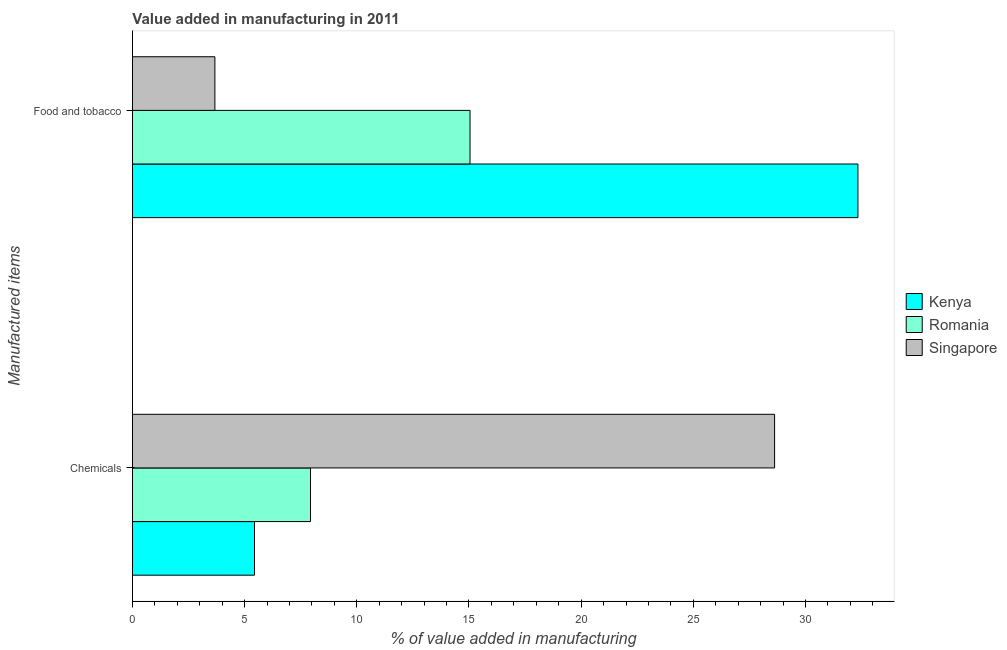Are the number of bars per tick equal to the number of legend labels?
Make the answer very short. Yes. Are the number of bars on each tick of the Y-axis equal?
Your answer should be very brief. Yes. What is the label of the 2nd group of bars from the top?
Give a very brief answer. Chemicals. What is the value added by manufacturing food and tobacco in Singapore?
Your response must be concise. 3.68. Across all countries, what is the maximum value added by  manufacturing chemicals?
Make the answer very short. 28.62. Across all countries, what is the minimum value added by  manufacturing chemicals?
Keep it short and to the point. 5.44. In which country was the value added by  manufacturing chemicals maximum?
Offer a very short reply. Singapore. In which country was the value added by manufacturing food and tobacco minimum?
Offer a terse response. Singapore. What is the total value added by manufacturing food and tobacco in the graph?
Offer a very short reply. 51.06. What is the difference between the value added by  manufacturing chemicals in Singapore and that in Kenya?
Your answer should be very brief. 23.18. What is the difference between the value added by  manufacturing chemicals in Kenya and the value added by manufacturing food and tobacco in Singapore?
Offer a very short reply. 1.76. What is the average value added by manufacturing food and tobacco per country?
Your response must be concise. 17.02. What is the difference between the value added by  manufacturing chemicals and value added by manufacturing food and tobacco in Romania?
Make the answer very short. -7.11. What is the ratio of the value added by manufacturing food and tobacco in Romania to that in Kenya?
Give a very brief answer. 0.47. In how many countries, is the value added by  manufacturing chemicals greater than the average value added by  manufacturing chemicals taken over all countries?
Offer a terse response. 1. What does the 3rd bar from the top in Food and tobacco represents?
Ensure brevity in your answer.  Kenya. What does the 1st bar from the bottom in Chemicals represents?
Ensure brevity in your answer.  Kenya. How many bars are there?
Give a very brief answer. 6. Are the values on the major ticks of X-axis written in scientific E-notation?
Ensure brevity in your answer.  No. Does the graph contain any zero values?
Offer a terse response. No. Where does the legend appear in the graph?
Offer a very short reply. Center right. How are the legend labels stacked?
Keep it short and to the point. Vertical. What is the title of the graph?
Keep it short and to the point. Value added in manufacturing in 2011. Does "Iceland" appear as one of the legend labels in the graph?
Ensure brevity in your answer.  No. What is the label or title of the X-axis?
Ensure brevity in your answer.  % of value added in manufacturing. What is the label or title of the Y-axis?
Your answer should be compact. Manufactured items. What is the % of value added in manufacturing in Kenya in Chemicals?
Ensure brevity in your answer.  5.44. What is the % of value added in manufacturing of Romania in Chemicals?
Make the answer very short. 7.94. What is the % of value added in manufacturing in Singapore in Chemicals?
Your answer should be very brief. 28.62. What is the % of value added in manufacturing of Kenya in Food and tobacco?
Give a very brief answer. 32.34. What is the % of value added in manufacturing of Romania in Food and tobacco?
Offer a terse response. 15.05. What is the % of value added in manufacturing in Singapore in Food and tobacco?
Offer a very short reply. 3.68. Across all Manufactured items, what is the maximum % of value added in manufacturing in Kenya?
Your response must be concise. 32.34. Across all Manufactured items, what is the maximum % of value added in manufacturing in Romania?
Provide a short and direct response. 15.05. Across all Manufactured items, what is the maximum % of value added in manufacturing of Singapore?
Keep it short and to the point. 28.62. Across all Manufactured items, what is the minimum % of value added in manufacturing of Kenya?
Offer a terse response. 5.44. Across all Manufactured items, what is the minimum % of value added in manufacturing of Romania?
Your response must be concise. 7.94. Across all Manufactured items, what is the minimum % of value added in manufacturing of Singapore?
Your answer should be very brief. 3.68. What is the total % of value added in manufacturing of Kenya in the graph?
Give a very brief answer. 37.78. What is the total % of value added in manufacturing of Romania in the graph?
Give a very brief answer. 22.99. What is the total % of value added in manufacturing in Singapore in the graph?
Keep it short and to the point. 32.3. What is the difference between the % of value added in manufacturing in Kenya in Chemicals and that in Food and tobacco?
Your answer should be very brief. -26.9. What is the difference between the % of value added in manufacturing in Romania in Chemicals and that in Food and tobacco?
Make the answer very short. -7.11. What is the difference between the % of value added in manufacturing in Singapore in Chemicals and that in Food and tobacco?
Give a very brief answer. 24.95. What is the difference between the % of value added in manufacturing of Kenya in Chemicals and the % of value added in manufacturing of Romania in Food and tobacco?
Your answer should be very brief. -9.61. What is the difference between the % of value added in manufacturing in Kenya in Chemicals and the % of value added in manufacturing in Singapore in Food and tobacco?
Offer a very short reply. 1.76. What is the difference between the % of value added in manufacturing in Romania in Chemicals and the % of value added in manufacturing in Singapore in Food and tobacco?
Provide a succinct answer. 4.26. What is the average % of value added in manufacturing of Kenya per Manufactured items?
Make the answer very short. 18.89. What is the average % of value added in manufacturing in Romania per Manufactured items?
Offer a terse response. 11.49. What is the average % of value added in manufacturing of Singapore per Manufactured items?
Offer a terse response. 16.15. What is the difference between the % of value added in manufacturing in Kenya and % of value added in manufacturing in Romania in Chemicals?
Your response must be concise. -2.5. What is the difference between the % of value added in manufacturing in Kenya and % of value added in manufacturing in Singapore in Chemicals?
Ensure brevity in your answer.  -23.18. What is the difference between the % of value added in manufacturing of Romania and % of value added in manufacturing of Singapore in Chemicals?
Ensure brevity in your answer.  -20.69. What is the difference between the % of value added in manufacturing of Kenya and % of value added in manufacturing of Romania in Food and tobacco?
Provide a succinct answer. 17.29. What is the difference between the % of value added in manufacturing of Kenya and % of value added in manufacturing of Singapore in Food and tobacco?
Offer a terse response. 28.66. What is the difference between the % of value added in manufacturing in Romania and % of value added in manufacturing in Singapore in Food and tobacco?
Provide a succinct answer. 11.37. What is the ratio of the % of value added in manufacturing of Kenya in Chemicals to that in Food and tobacco?
Your answer should be very brief. 0.17. What is the ratio of the % of value added in manufacturing of Romania in Chemicals to that in Food and tobacco?
Ensure brevity in your answer.  0.53. What is the ratio of the % of value added in manufacturing of Singapore in Chemicals to that in Food and tobacco?
Offer a terse response. 7.79. What is the difference between the highest and the second highest % of value added in manufacturing of Kenya?
Give a very brief answer. 26.9. What is the difference between the highest and the second highest % of value added in manufacturing of Romania?
Ensure brevity in your answer.  7.11. What is the difference between the highest and the second highest % of value added in manufacturing in Singapore?
Your answer should be very brief. 24.95. What is the difference between the highest and the lowest % of value added in manufacturing in Kenya?
Ensure brevity in your answer.  26.9. What is the difference between the highest and the lowest % of value added in manufacturing in Romania?
Give a very brief answer. 7.11. What is the difference between the highest and the lowest % of value added in manufacturing in Singapore?
Make the answer very short. 24.95. 